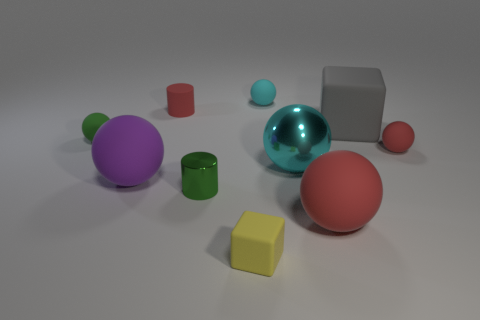Subtract all green matte balls. How many balls are left? 5 Subtract 1 balls. How many balls are left? 5 Subtract all purple cubes. How many red balls are left? 2 Subtract all red spheres. How many spheres are left? 4 Subtract all cyan spheres. Subtract all red cylinders. How many spheres are left? 4 Subtract all spheres. How many objects are left? 4 Subtract all tiny red spheres. Subtract all purple things. How many objects are left? 8 Add 3 small yellow blocks. How many small yellow blocks are left? 4 Add 2 tiny balls. How many tiny balls exist? 5 Subtract 0 brown blocks. How many objects are left? 10 